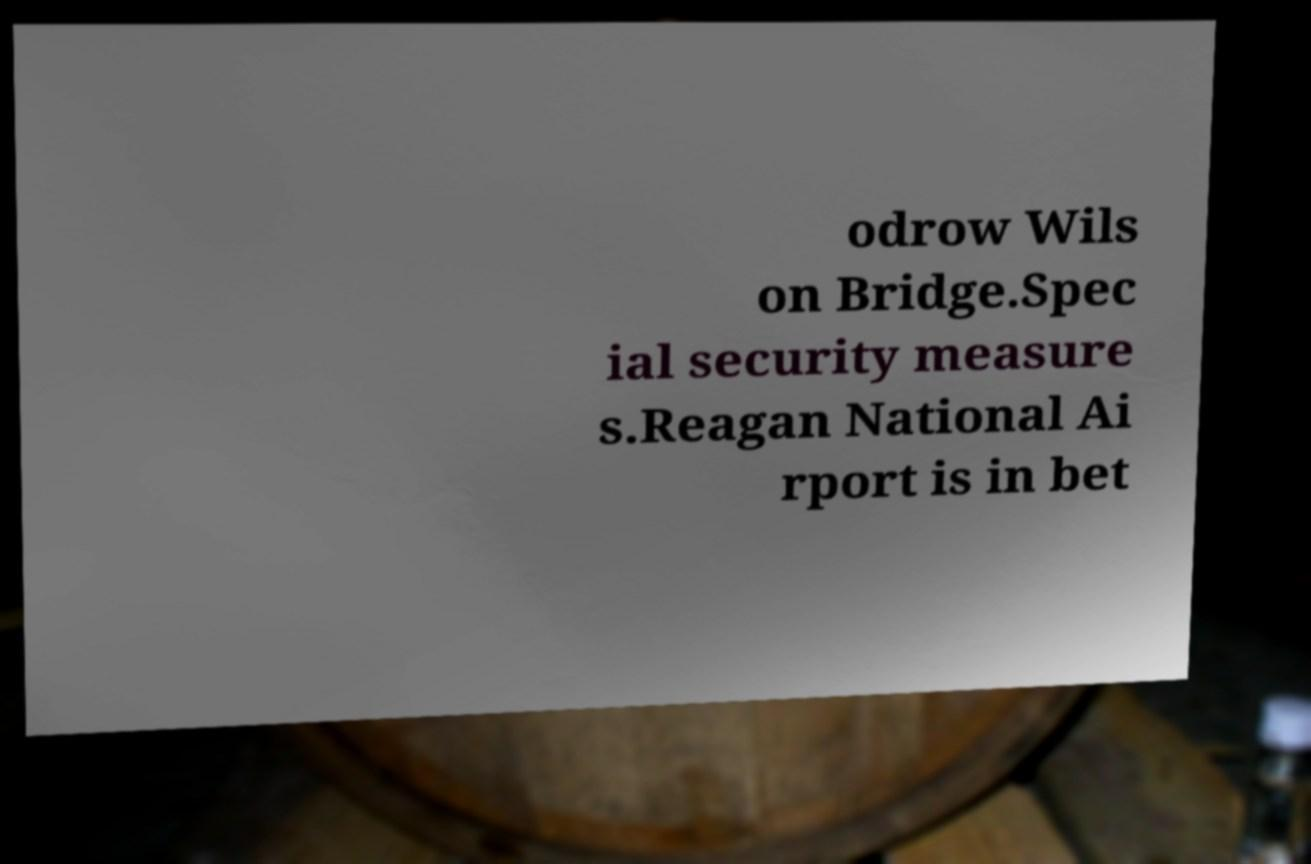There's text embedded in this image that I need extracted. Can you transcribe it verbatim? odrow Wils on Bridge.Spec ial security measure s.Reagan National Ai rport is in bet 